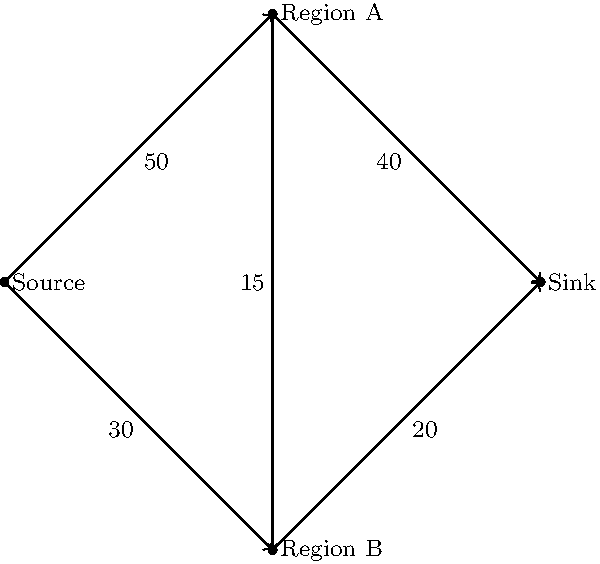Given the network flow diagram representing the influence of political music on voter turnout in different regions, what is the maximum flow from the Source (your music production) to the Sink (total voter turnout)? Assume that the numbers on the edges represent the maximum number of thousands of voters that can be influenced through each channel. To solve this network flow problem and find the maximum flow, we'll use the Ford-Fulkerson algorithm:

1. Initialize flow to 0 for all edges.

2. Find an augmenting path from Source to Sink:
   Path 1: Source -> Region A -> Sink (min capacity: 40)
   Update flow: 40
   Residual capacities: Source->A: 10, A->Sink: 0, Source->B: 30, B->Sink: 20, A->B: 15

3. Find another augmenting path:
   Path 2: Source -> Region B -> Sink (min capacity: 20)
   Update flow: 40 + 20 = 60
   Residual capacities: Source->A: 10, A->Sink: 0, Source->B: 10, B->Sink: 0, A->B: 15

4. Find another augmenting path:
   Path 3: Source -> Region A -> Region B -> Sink (min capacity: 10)
   Update flow: 60 + 10 = 70
   Residual capacities: Source->A: 0, A->Sink: 0, Source->B: 10, B->Sink: 0, A->B: 5

5. No more augmenting paths exist, so the maximum flow is 70.

The maximum flow represents the maximum number of thousands of voters that can be influenced through the network, which is 70,000 voters.
Answer: 70,000 voters 